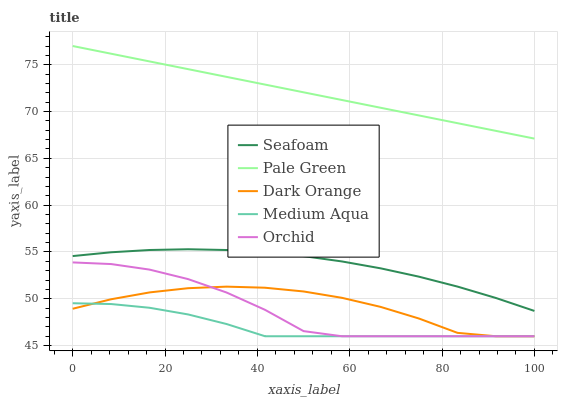Does Medium Aqua have the minimum area under the curve?
Answer yes or no. Yes. Does Pale Green have the maximum area under the curve?
Answer yes or no. Yes. Does Pale Green have the minimum area under the curve?
Answer yes or no. No. Does Medium Aqua have the maximum area under the curve?
Answer yes or no. No. Is Pale Green the smoothest?
Answer yes or no. Yes. Is Orchid the roughest?
Answer yes or no. Yes. Is Medium Aqua the smoothest?
Answer yes or no. No. Is Medium Aqua the roughest?
Answer yes or no. No. Does Dark Orange have the lowest value?
Answer yes or no. Yes. Does Pale Green have the lowest value?
Answer yes or no. No. Does Pale Green have the highest value?
Answer yes or no. Yes. Does Medium Aqua have the highest value?
Answer yes or no. No. Is Dark Orange less than Seafoam?
Answer yes or no. Yes. Is Pale Green greater than Seafoam?
Answer yes or no. Yes. Does Orchid intersect Dark Orange?
Answer yes or no. Yes. Is Orchid less than Dark Orange?
Answer yes or no. No. Is Orchid greater than Dark Orange?
Answer yes or no. No. Does Dark Orange intersect Seafoam?
Answer yes or no. No. 